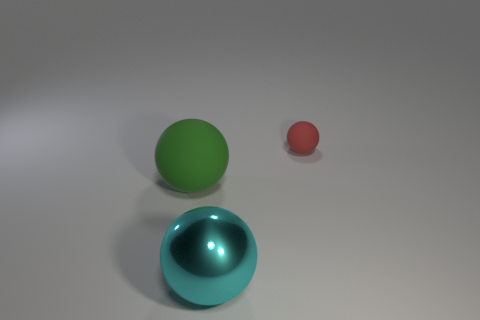What is the shape of the rubber thing that is to the left of the matte ball on the right side of the big ball behind the cyan shiny ball?
Give a very brief answer. Sphere. What is the color of the other shiny thing that is the same shape as the tiny red object?
Make the answer very short. Cyan. How big is the object that is behind the big cyan sphere and right of the green ball?
Make the answer very short. Small. There is a thing on the right side of the thing that is in front of the large green matte ball; what number of spheres are behind it?
Your answer should be compact. 0. What number of tiny things are either yellow metallic objects or red matte objects?
Offer a very short reply. 1. Are the thing that is on the right side of the big metallic ball and the green thing made of the same material?
Offer a very short reply. Yes. What is the material of the large object to the left of the large sphere on the right side of the matte ball in front of the small red rubber sphere?
Ensure brevity in your answer.  Rubber. Are there any other things that have the same size as the red rubber sphere?
Give a very brief answer. No. What number of matte objects are red balls or green objects?
Your answer should be very brief. 2. Are there any large metal balls?
Your response must be concise. Yes. 